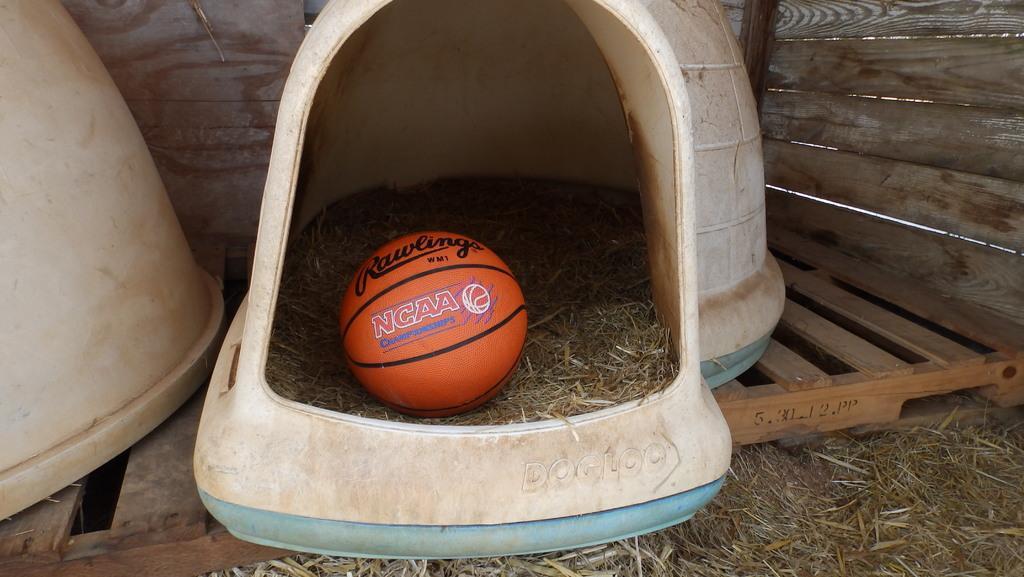Please provide a concise description of this image. There is an orange color ball, which is on the grass, which is in the white color object which is arranged on the wooden floor, along with other objects, near dry grass and a wooden wall. 